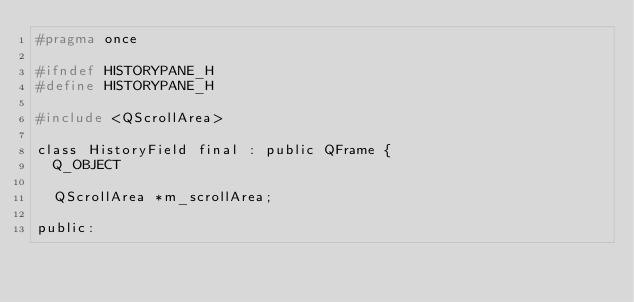<code> <loc_0><loc_0><loc_500><loc_500><_C_>#pragma once

#ifndef HISTORYPANE_H
#define HISTORYPANE_H

#include <QScrollArea>

class HistoryField final : public QFrame {
  Q_OBJECT

  QScrollArea *m_scrollArea;

public:</code> 